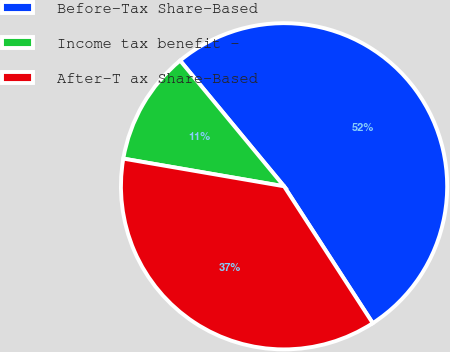<chart> <loc_0><loc_0><loc_500><loc_500><pie_chart><fcel>Before-Tax Share-Based<fcel>Income tax benefit -<fcel>After-T ax Share-Based<nl><fcel>51.84%<fcel>11.29%<fcel>36.86%<nl></chart> 